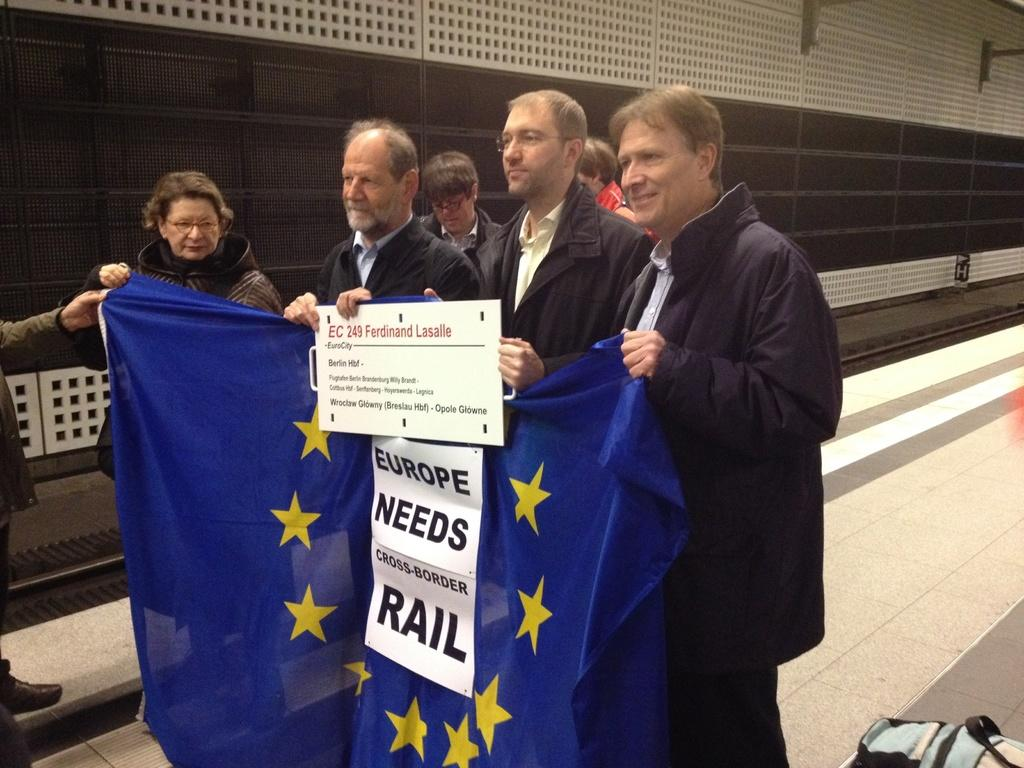How many people are in the image? There is a group of people in the image, but the exact number is not specified. What are the people doing in the image? The people are standing on a path in the image. What are some people holding in the image? Some people are holding a board in the image. What can be seen in the background of the image? There is a blue flag and a wall behind the people in the image. What type of plants can be seen growing on the marble surface in the image? There are no plants or marble surfaces present in the image. 